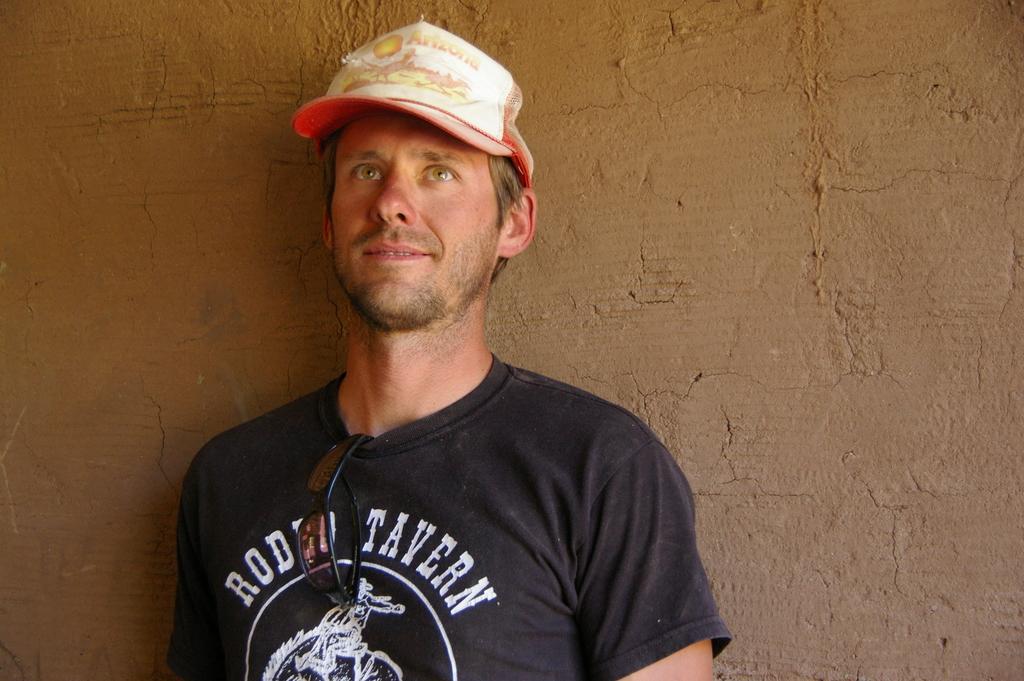In one or two sentences, can you explain what this image depicts? A man is standing wearing cap, t shirt, google. This is wall. 